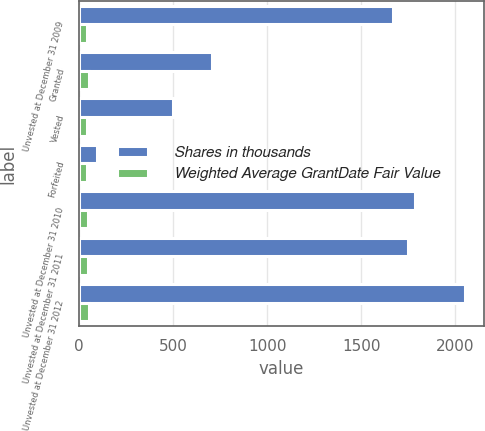<chart> <loc_0><loc_0><loc_500><loc_500><stacked_bar_chart><ecel><fcel>Unvested at December 31 2009<fcel>Granted<fcel>Vested<fcel>Forfeited<fcel>Unvested at December 31 2010<fcel>Unvested at December 31 2011<fcel>Unvested at December 31 2012<nl><fcel>Shares in thousands<fcel>1671<fcel>704<fcel>499<fcel>92<fcel>1784<fcel>1748<fcel>2051<nl><fcel>Weighted Average GrantDate Fair Value<fcel>41.99<fcel>49.43<fcel>42<fcel>39.56<fcel>45.05<fcel>48.96<fcel>53.91<nl></chart> 